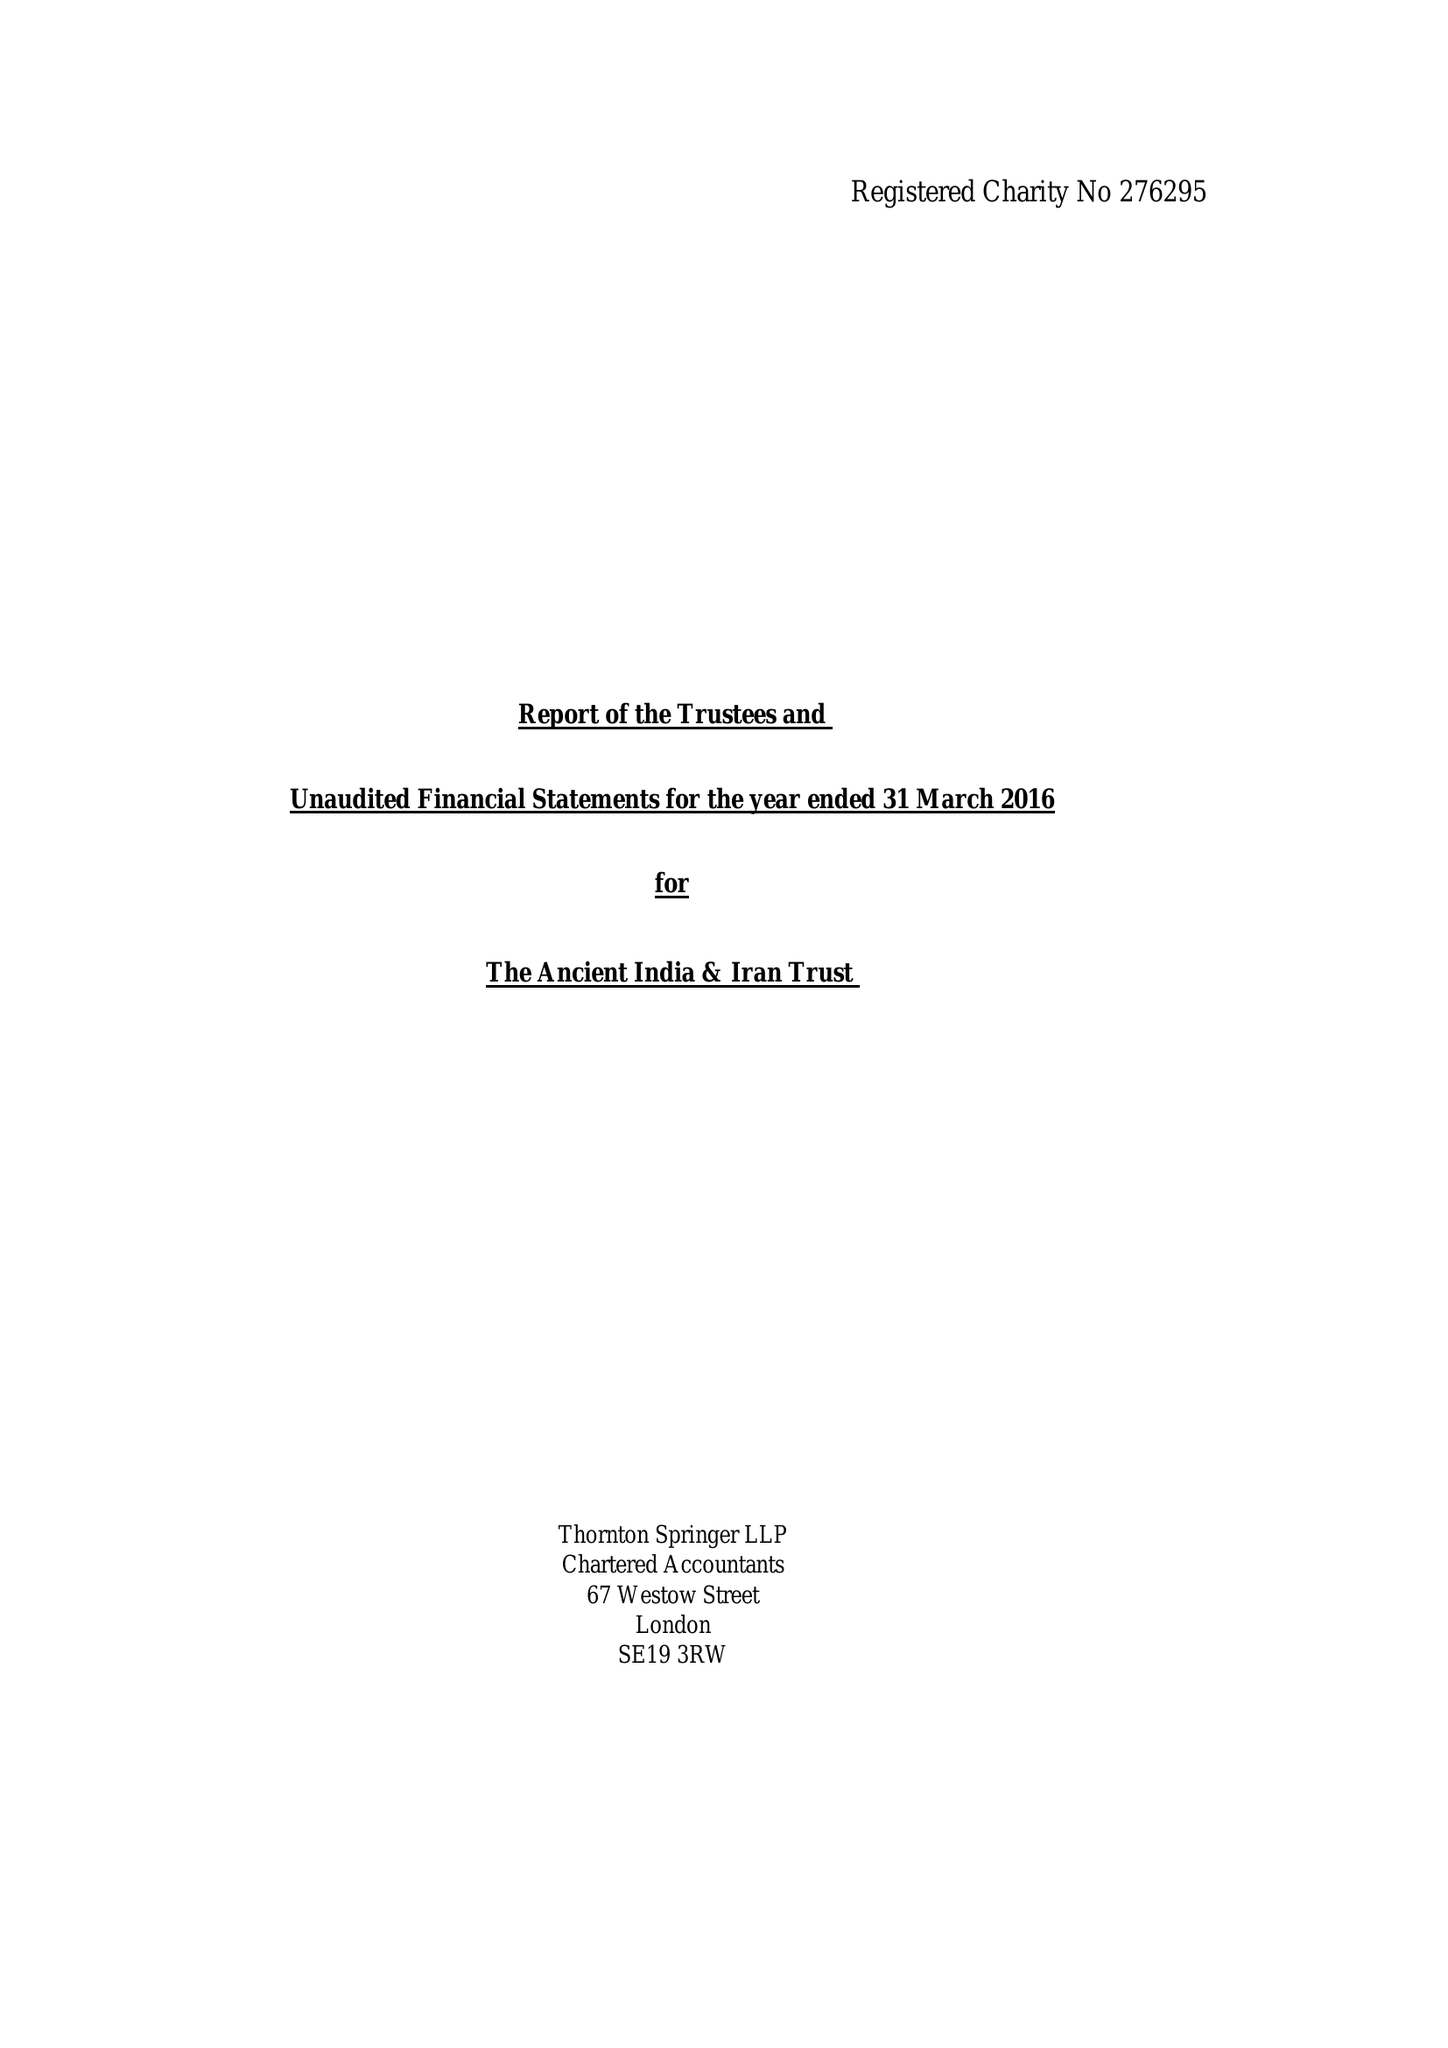What is the value for the spending_annually_in_british_pounds?
Answer the question using a single word or phrase. 110729.00 